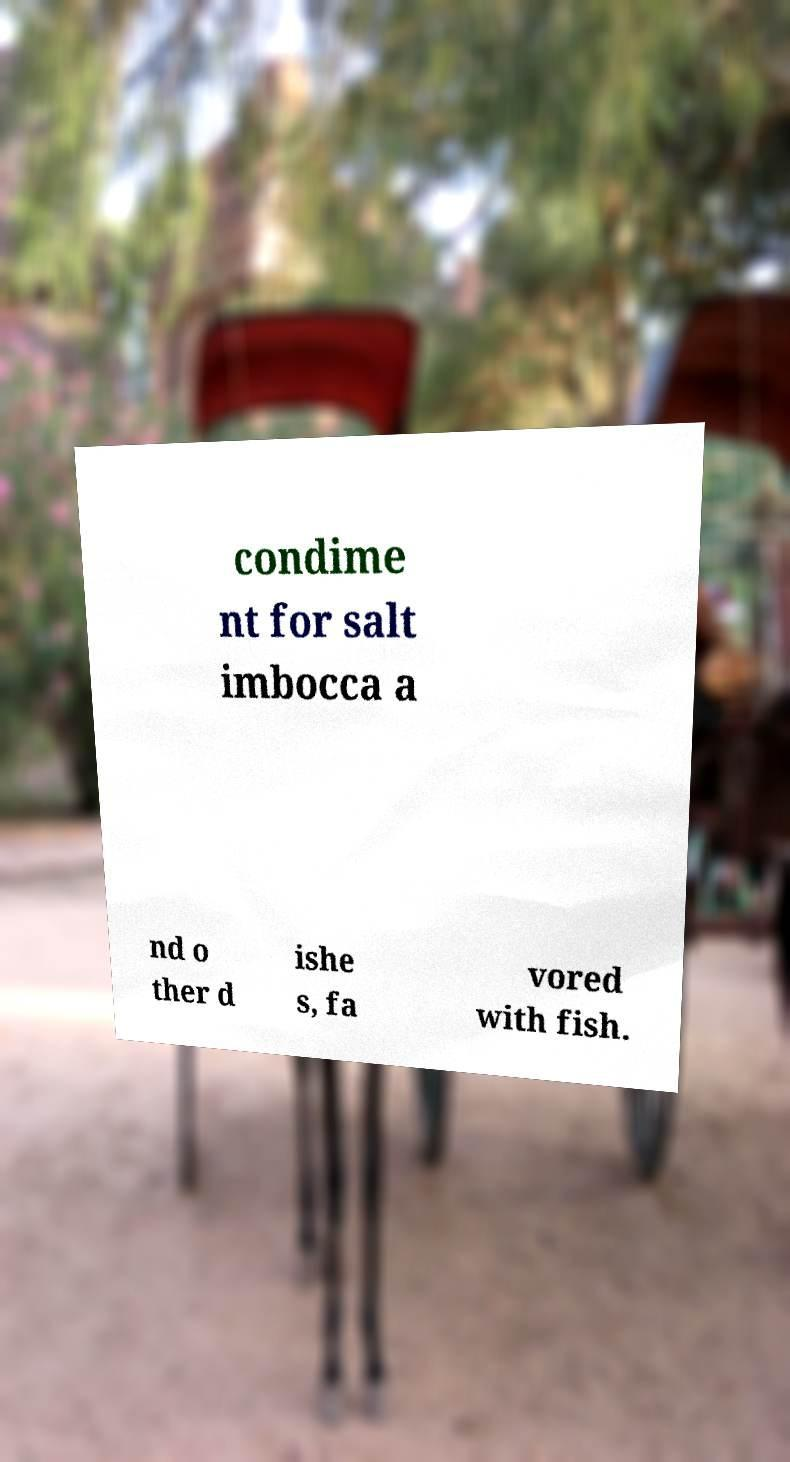For documentation purposes, I need the text within this image transcribed. Could you provide that? condime nt for salt imbocca a nd o ther d ishe s, fa vored with fish. 